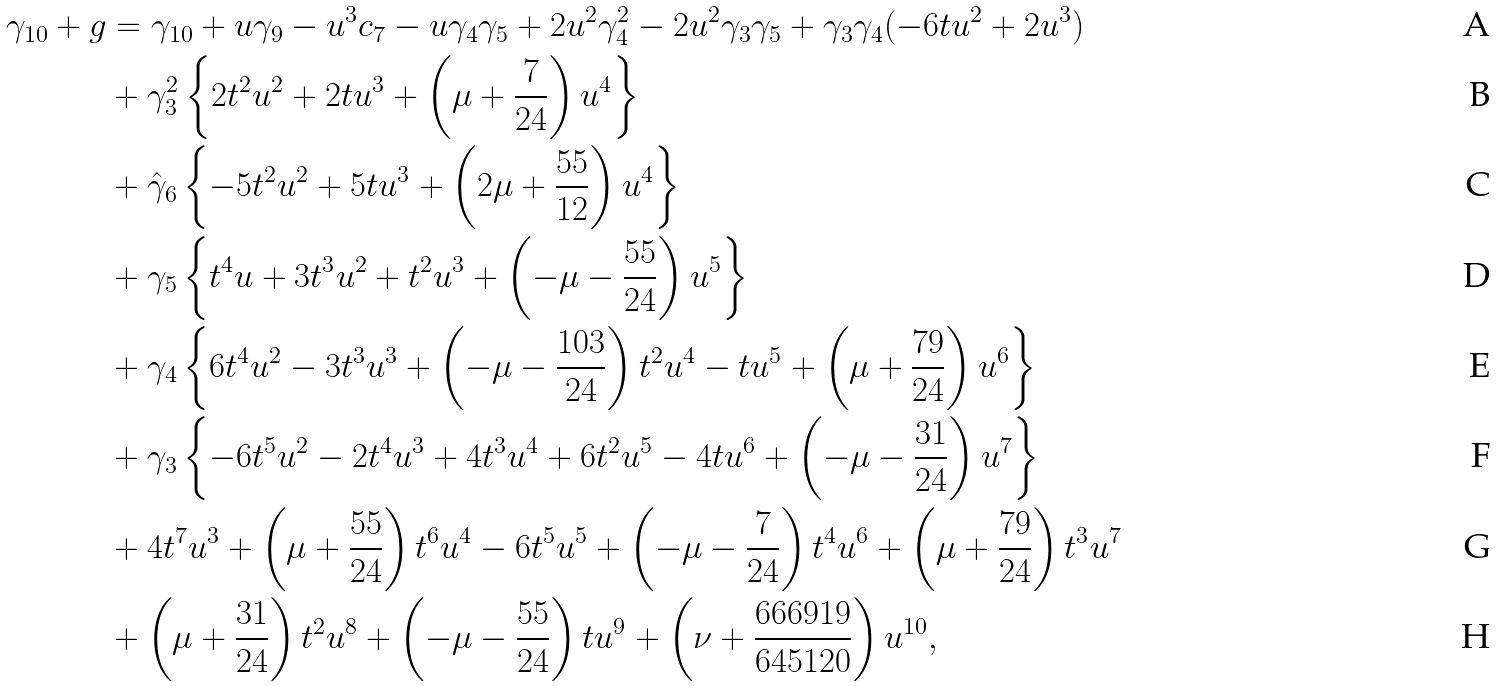<formula> <loc_0><loc_0><loc_500><loc_500>\gamma _ { 1 0 } + g & = \gamma _ { 1 0 } + u \gamma _ { 9 } - u ^ { 3 } c _ { 7 } - u \gamma _ { 4 } \gamma _ { 5 } + 2 u ^ { 2 } \gamma _ { 4 } ^ { 2 } - 2 u ^ { 2 } \gamma _ { 3 } \gamma _ { 5 } + \gamma _ { 3 } \gamma _ { 4 } ( - 6 t u ^ { 2 } + 2 u ^ { 3 } ) \\ & + \gamma _ { 3 } ^ { 2 } \left \{ 2 t ^ { 2 } u ^ { 2 } + 2 t u ^ { 3 } + \left ( \mu + \frac { 7 } { 2 4 } \right ) u ^ { 4 } \right \} \\ & + \hat { \gamma } _ { 6 } \left \{ - 5 t ^ { 2 } u ^ { 2 } + 5 t u ^ { 3 } + \left ( 2 \mu + \frac { 5 5 } { 1 2 } \right ) u ^ { 4 } \right \} \\ & + \gamma _ { 5 } \left \{ t ^ { 4 } u + 3 t ^ { 3 } u ^ { 2 } + t ^ { 2 } u ^ { 3 } + \left ( - \mu - \frac { 5 5 } { 2 4 } \right ) u ^ { 5 } \right \} \\ & + \gamma _ { 4 } \left \{ 6 t ^ { 4 } u ^ { 2 } - 3 t ^ { 3 } u ^ { 3 } + \left ( - \mu - \frac { 1 0 3 } { 2 4 } \right ) t ^ { 2 } u ^ { 4 } - t u ^ { 5 } + \left ( \mu + \frac { 7 9 } { 2 4 } \right ) u ^ { 6 } \right \} \\ & + \gamma _ { 3 } \left \{ - 6 t ^ { 5 } u ^ { 2 } - 2 t ^ { 4 } u ^ { 3 } + 4 t ^ { 3 } u ^ { 4 } + 6 t ^ { 2 } u ^ { 5 } - 4 t u ^ { 6 } + \left ( - \mu - \frac { 3 1 } { 2 4 } \right ) u ^ { 7 } \right \} \\ & + 4 t ^ { 7 } u ^ { 3 } + \left ( \mu + \frac { 5 5 } { 2 4 } \right ) t ^ { 6 } u ^ { 4 } - 6 t ^ { 5 } u ^ { 5 } + \left ( - \mu - \frac { 7 } { 2 4 } \right ) t ^ { 4 } u ^ { 6 } + \left ( \mu + \frac { 7 9 } { 2 4 } \right ) t ^ { 3 } u ^ { 7 } \\ & + \left ( \mu + \frac { 3 1 } { 2 4 } \right ) t ^ { 2 } u ^ { 8 } + \left ( - \mu - \frac { 5 5 } { 2 4 } \right ) t u ^ { 9 } + \left ( \nu + \frac { 6 6 6 9 1 9 } { 6 4 5 1 2 0 } \right ) u ^ { 1 0 } ,</formula> 